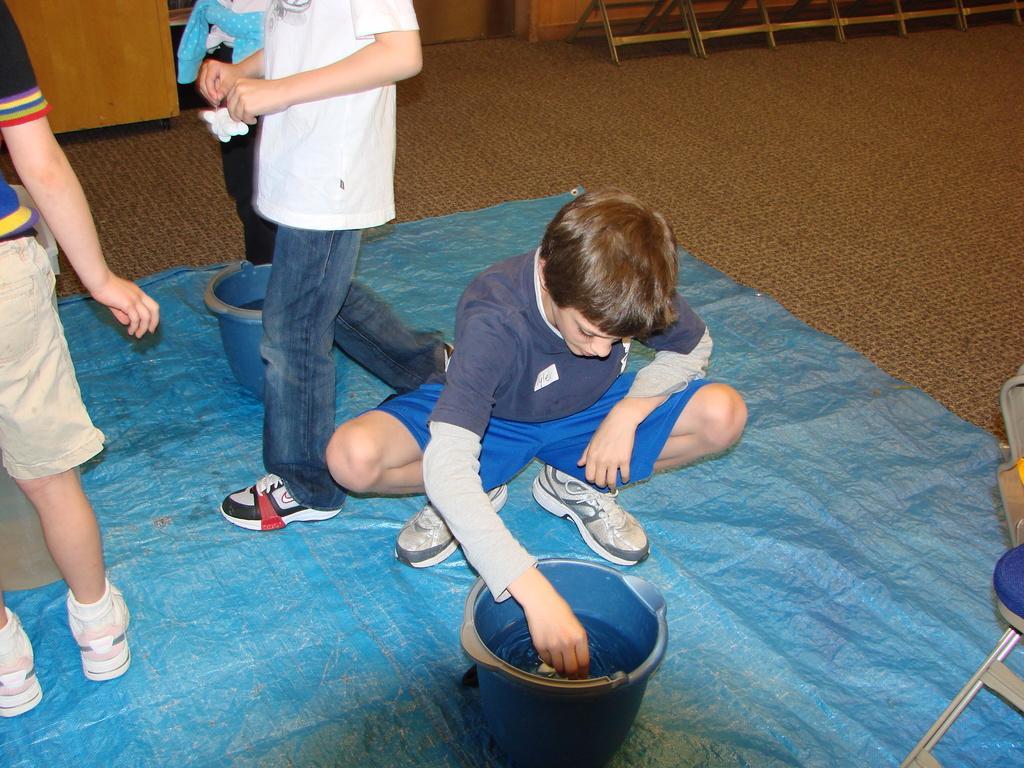Please provide a concise description of this image. In this image there are persons. In the center there is a boy who is in squatting position, in front of the boy there is a bucket and in the background there are persons standing and walking. On the floor there is a mat which is blue in colour. 